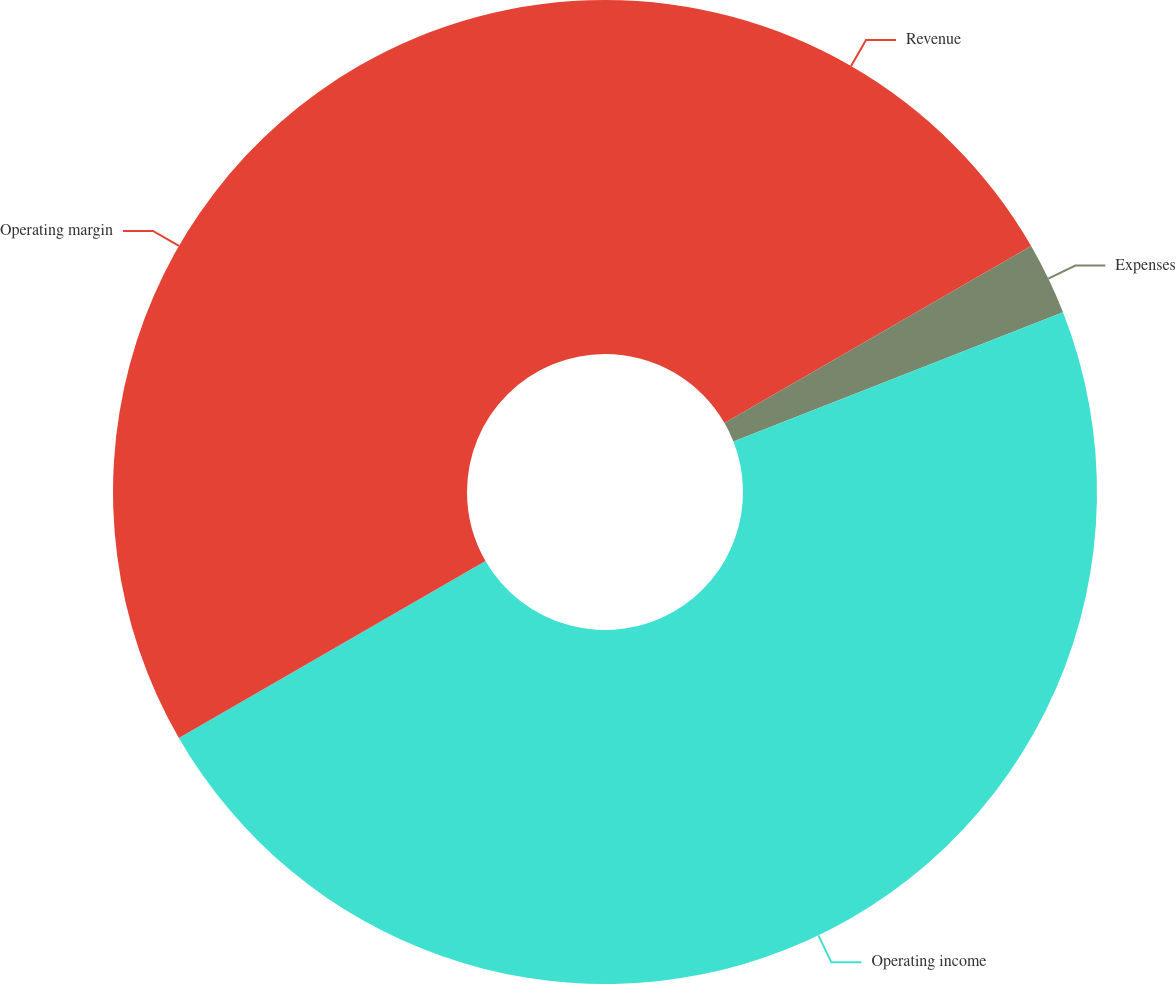Convert chart to OTSL. <chart><loc_0><loc_0><loc_500><loc_500><pie_chart><fcel>Revenue<fcel>Expenses<fcel>Operating income<fcel>Operating margin<nl><fcel>16.67%<fcel>2.38%<fcel>47.62%<fcel>33.33%<nl></chart> 